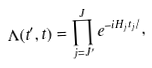Convert formula to latex. <formula><loc_0><loc_0><loc_500><loc_500>\Lambda ( t ^ { \prime } , t ) = \prod _ { j = J ^ { \prime } } ^ { J } e ^ { - i H _ { j } t _ { j } / } ,</formula> 